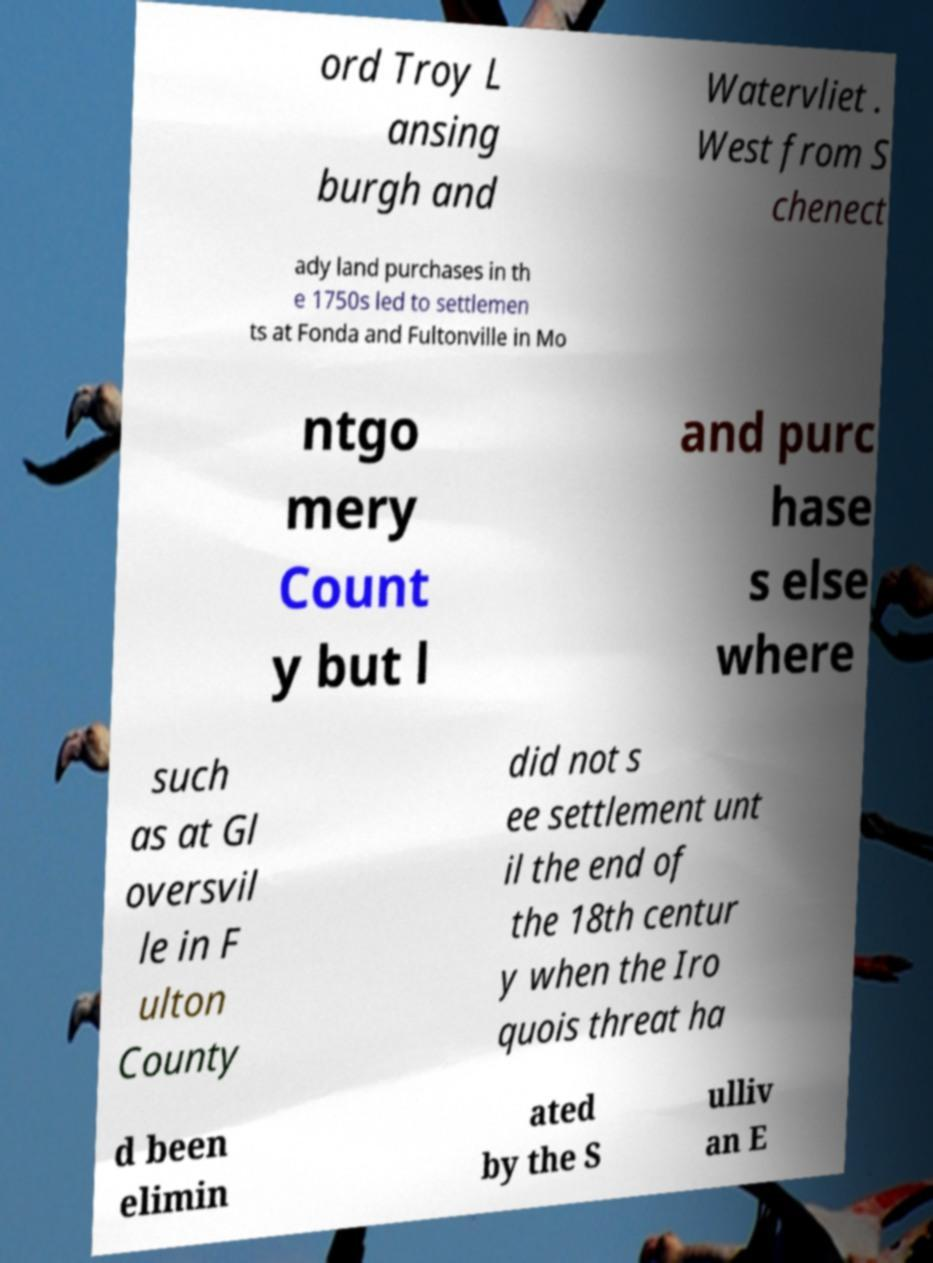I need the written content from this picture converted into text. Can you do that? ord Troy L ansing burgh and Watervliet . West from S chenect ady land purchases in th e 1750s led to settlemen ts at Fonda and Fultonville in Mo ntgo mery Count y but l and purc hase s else where such as at Gl oversvil le in F ulton County did not s ee settlement unt il the end of the 18th centur y when the Iro quois threat ha d been elimin ated by the S ulliv an E 